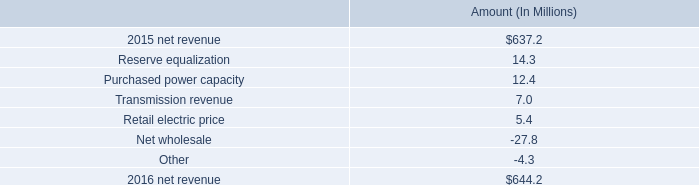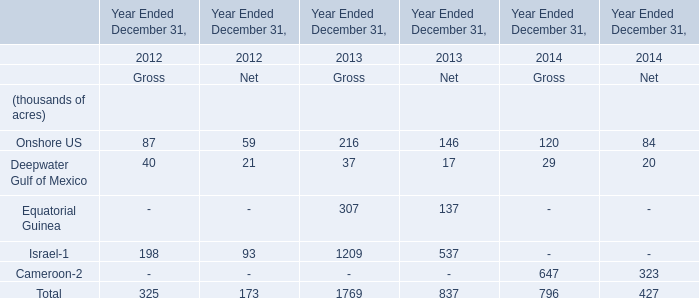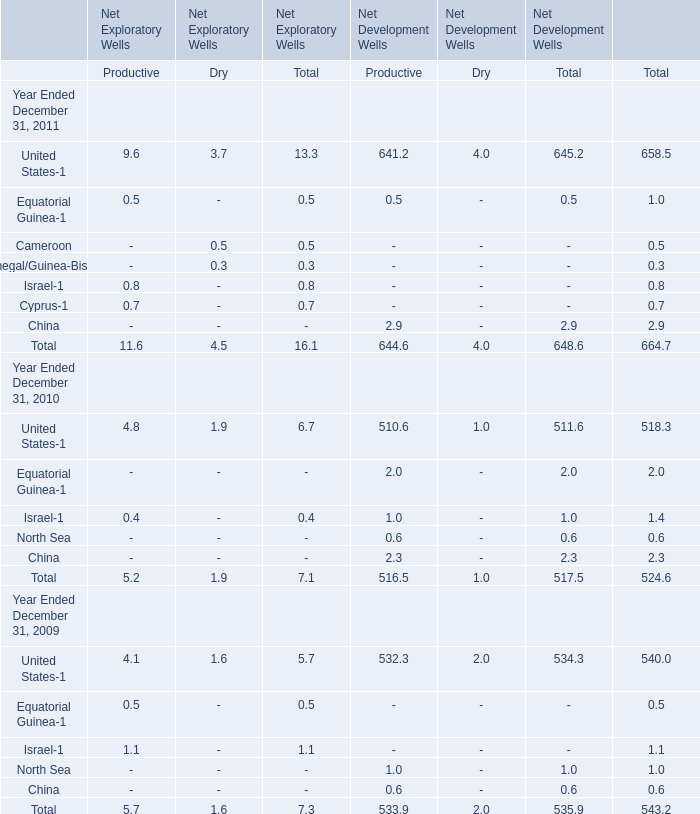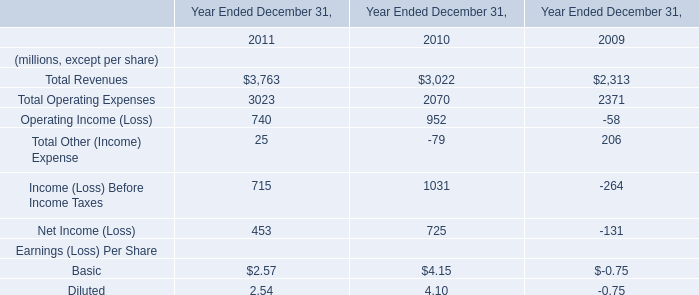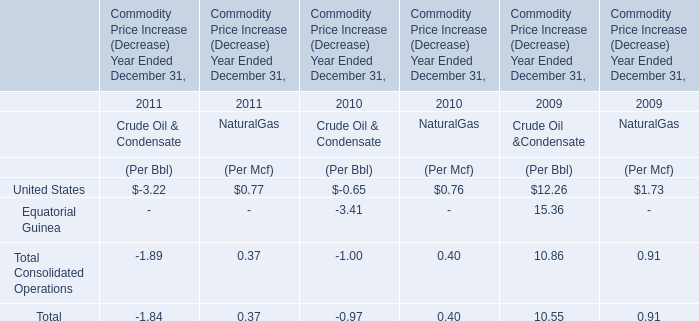In the year with the greatest proportion of Onshore US, what is the proportion of Onshore US to the total? 
Computations: (216 / 1769)
Answer: 0.1221. 